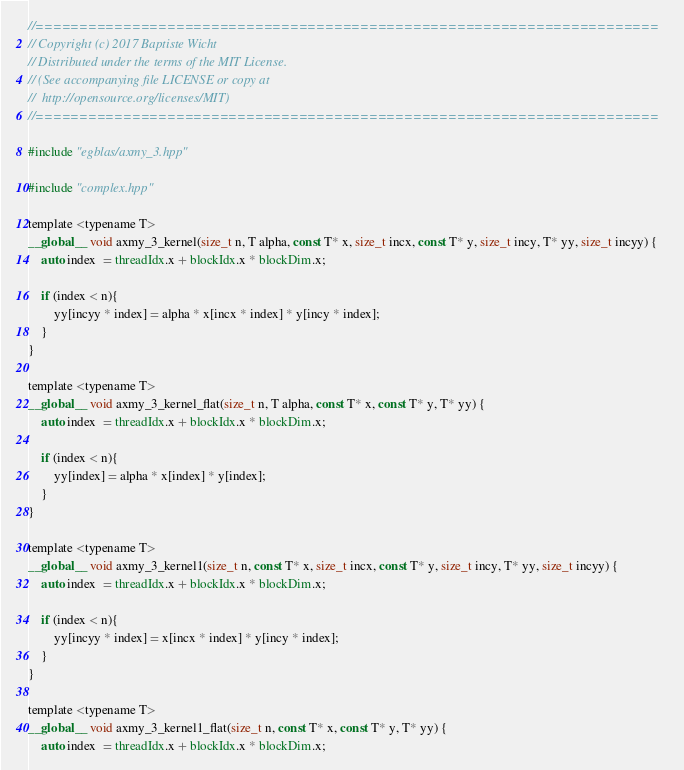Convert code to text. <code><loc_0><loc_0><loc_500><loc_500><_Cuda_>//=======================================================================
// Copyright (c) 2017 Baptiste Wicht
// Distributed under the terms of the MIT License.
// (See accompanying file LICENSE or copy at
//  http://opensource.org/licenses/MIT)
//=======================================================================

#include "egblas/axmy_3.hpp"

#include "complex.hpp"

template <typename T>
__global__ void axmy_3_kernel(size_t n, T alpha, const T* x, size_t incx, const T* y, size_t incy, T* yy, size_t incyy) {
    auto index  = threadIdx.x + blockIdx.x * blockDim.x;

    if (index < n){
        yy[incyy * index] = alpha * x[incx * index] * y[incy * index];
    }
}

template <typename T>
__global__ void axmy_3_kernel_flat(size_t n, T alpha, const T* x, const T* y, T* yy) {
    auto index  = threadIdx.x + blockIdx.x * blockDim.x;

    if (index < n){
        yy[index] = alpha * x[index] * y[index];
    }
}

template <typename T>
__global__ void axmy_3_kernel1(size_t n, const T* x, size_t incx, const T* y, size_t incy, T* yy, size_t incyy) {
    auto index  = threadIdx.x + blockIdx.x * blockDim.x;

    if (index < n){
        yy[incyy * index] = x[incx * index] * y[incy * index];
    }
}

template <typename T>
__global__ void axmy_3_kernel1_flat(size_t n, const T* x, const T* y, T* yy) {
    auto index  = threadIdx.x + blockIdx.x * blockDim.x;
</code> 